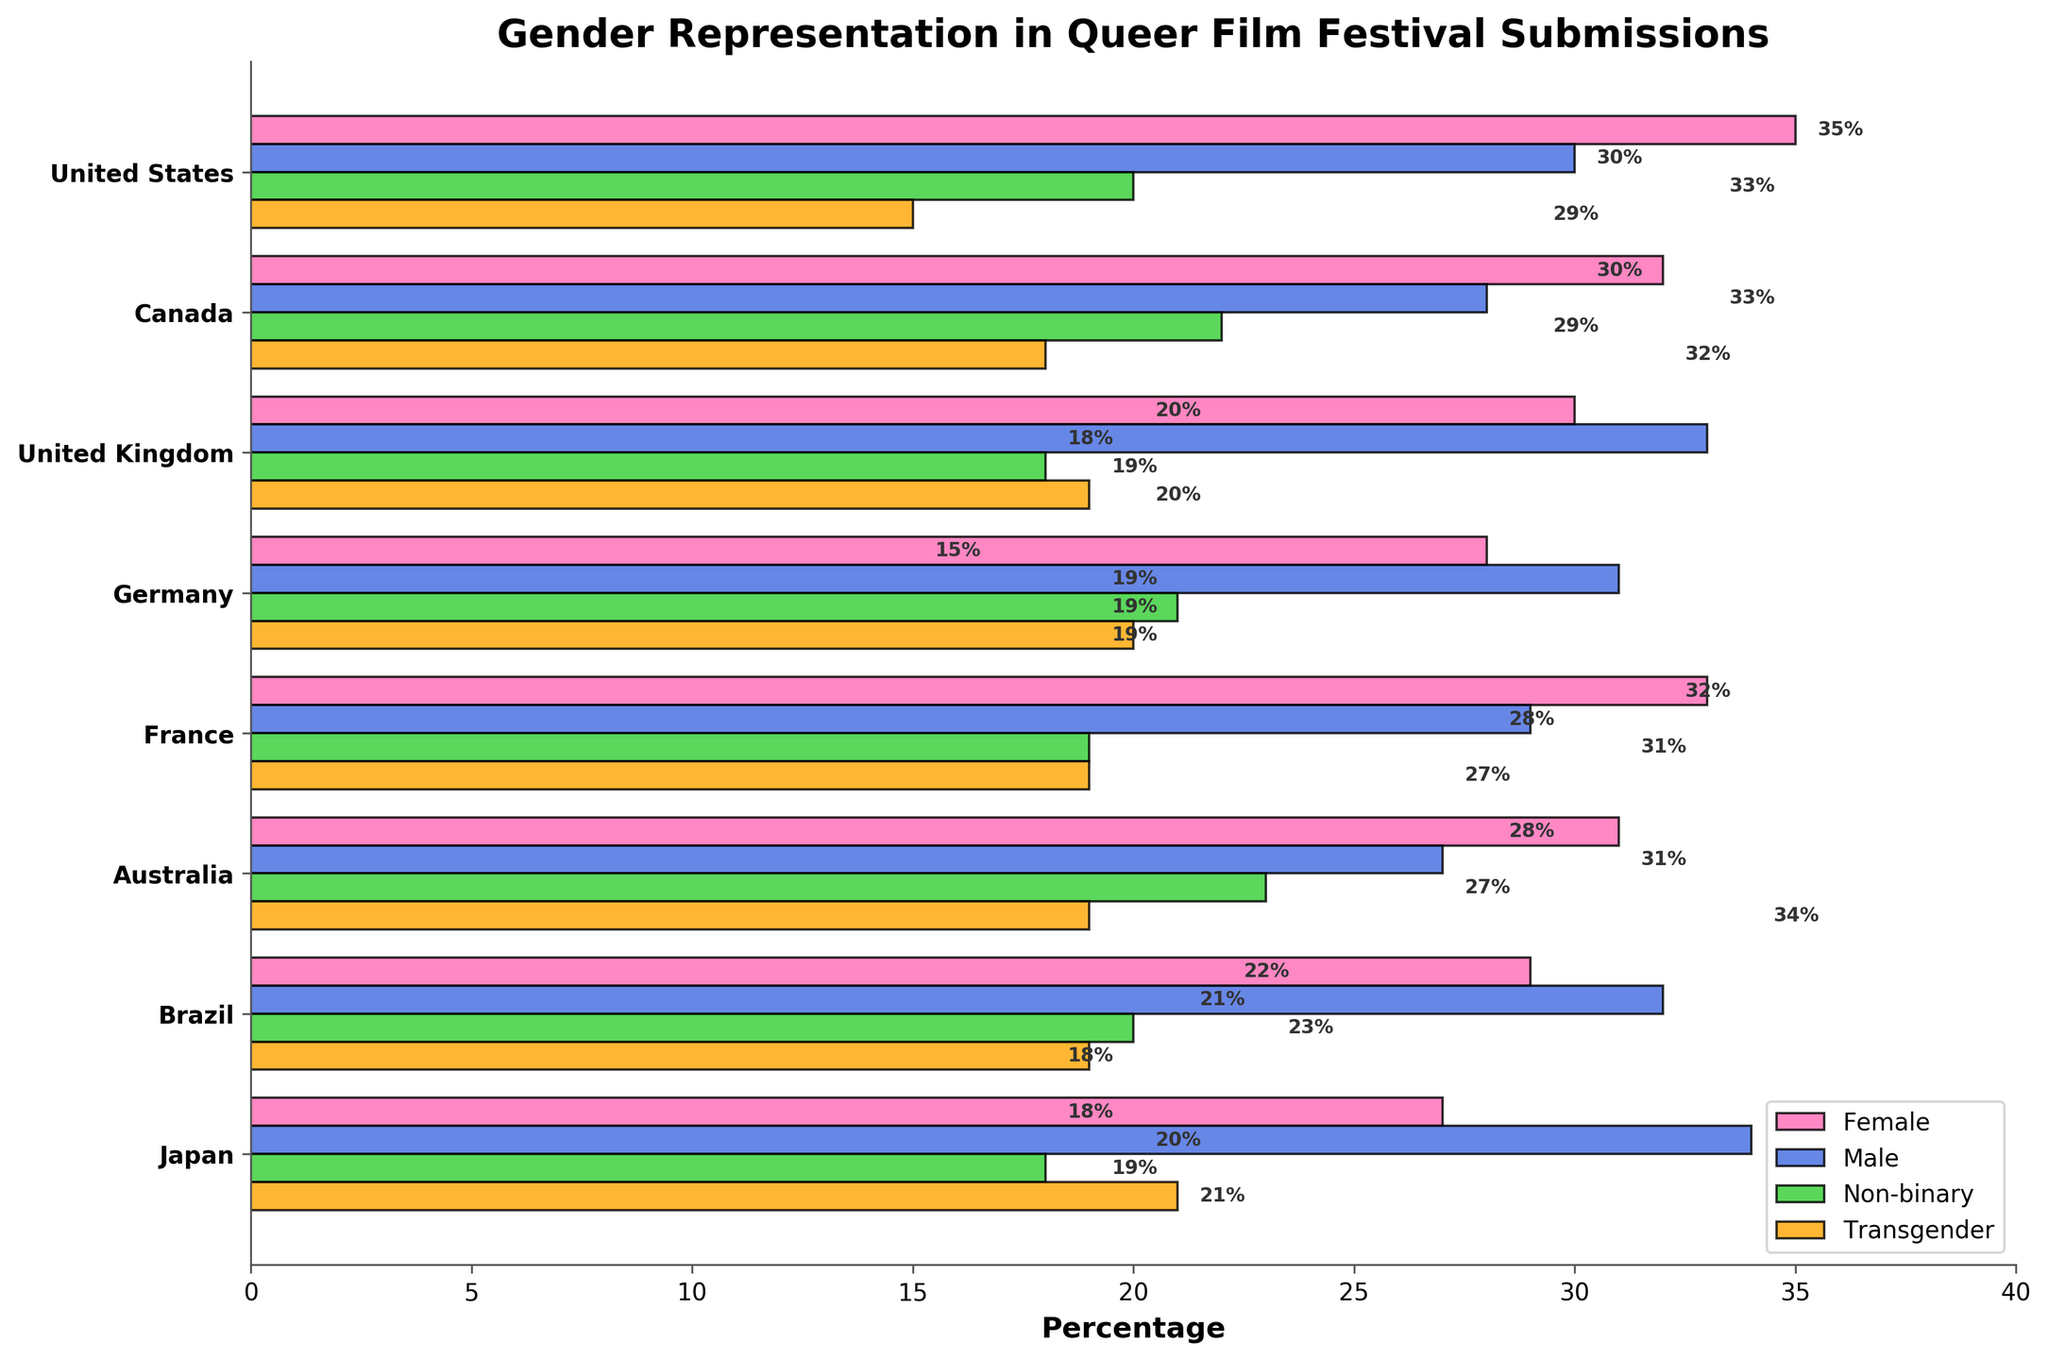Which country has the highest percentage of transgender film submissions? By looking at the bar lengths for transgender percentages and comparing them across countries, the longest bar represents Japan with 21%.
Answer: Japan Which gender has the least representation in submissions from Germany? By comparing the bar lengths for Germany, the shortest bar is for females with 28%.
Answer: Female What is the combined percentage of non-binary film submissions from Canada and the United Kingdom? Find the non-binary percentage for both countries (22% for Canada and 18% for the UK) and add them together: 22 + 18 = 40.
Answer: 40 Compare the percentage of male submissions from Brazil and the United States. Which country has a higher percentage? Look at the male bars for both Brazil and the United States; Brazil has 32% while the United States has 30%.
Answer: Brazil What is the difference in transgender submission percentages between Australia and France? Subtract the transgender percentage of France (19%) from that of Australia (19%): 19 - 19 = 0.
Answer: 0 Is the percentage of female submissions higher in the United States or Canada? Compare the female bars for the United States (35%) and Canada (32%), the United States has a higher percentage.
Answer: United States What is the average percentage of male submissions across all countries? Sum the male percentages from all countries (30 + 28 + 33 + 31 + 29 + 27 + 32 + 34 = 244) and divide by the number of countries (7): 244 / 7 ≈ 34.86.
Answer: 34.86 Which country has the highest overall percentage of female submissions? Identify the longest female bar: the United States with 35%.
Answer: United States What is the gender distribution in terms of submission percentage for Japan? Look at the bars for Japan: Female (27%), Male (34%), Non-binary (18%), Transgender (21%).
Answer: Female (27%), Male (34%), Non-binary (18%), Transgender (21%) In which country is the representation of non-binary submissions greater than that of male submissions? Compare non-binary and male bars for each country; in Australia, non-binary (23%) is greater than male (27%).
Answer: Australia 